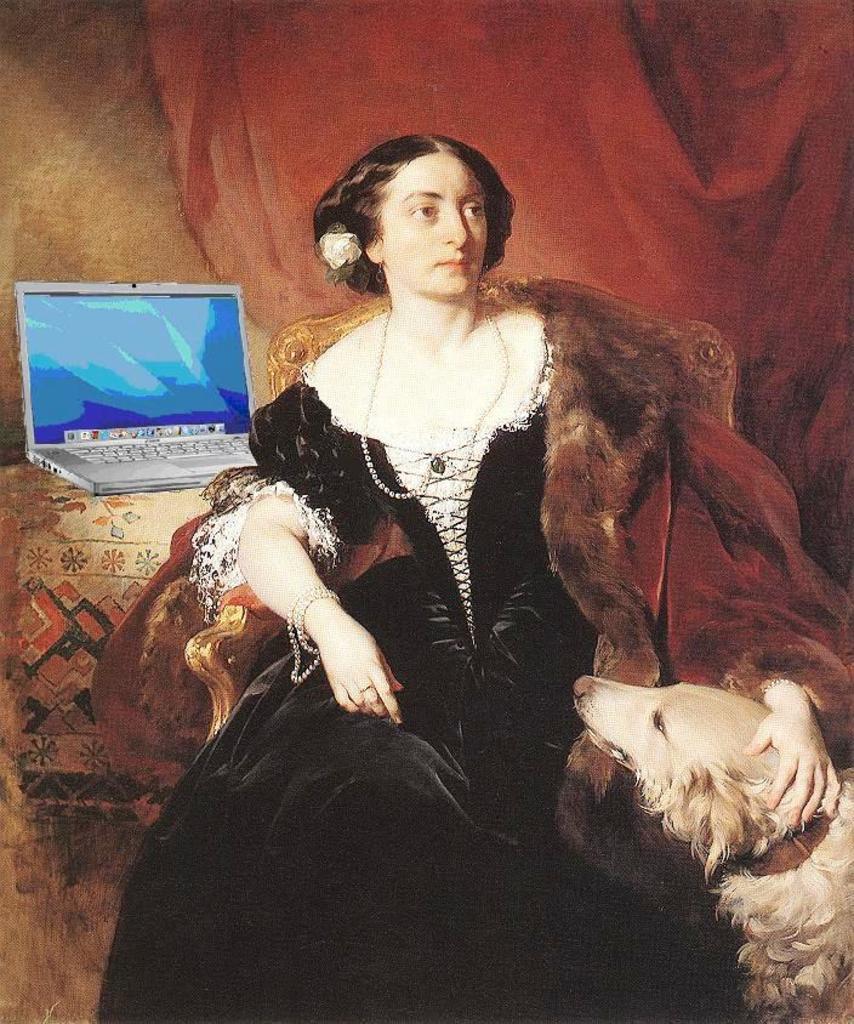Can you describe this image briefly? This is a painting,a woman sitting on the chair. Beside her there is a laptop. On the right there is a dog. 